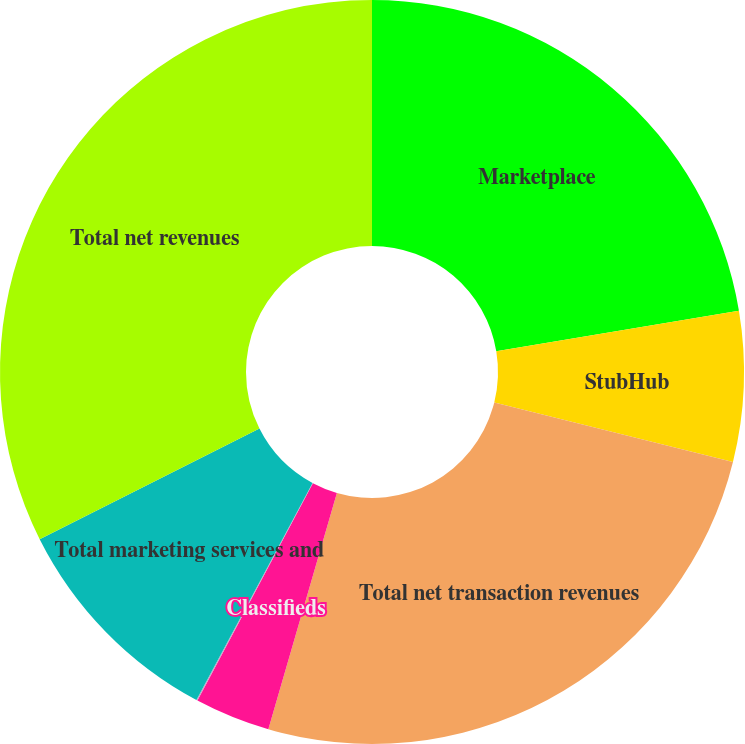Convert chart to OTSL. <chart><loc_0><loc_0><loc_500><loc_500><pie_chart><fcel>Marketplace<fcel>StubHub<fcel>Total net transaction revenues<fcel>Classifieds<fcel>StubHub Corporate and other<fcel>Total marketing services and<fcel>Total net revenues<nl><fcel>22.37%<fcel>6.52%<fcel>25.61%<fcel>3.28%<fcel>0.05%<fcel>9.76%<fcel>32.42%<nl></chart> 